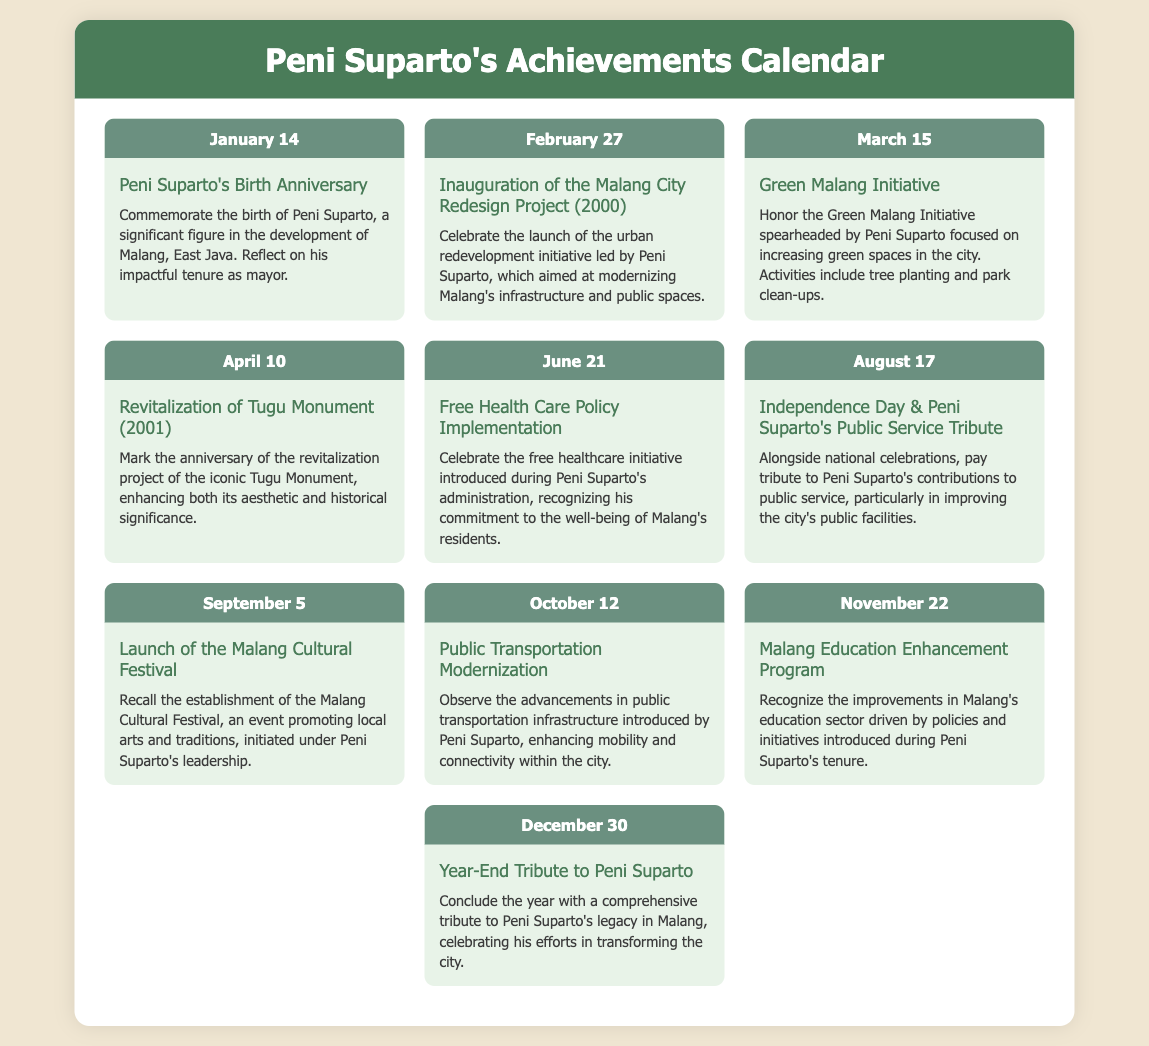What event is celebrated on January 14? The event celebrated on January 14 is Peni Suparto's Birth Anniversary, marked for his significance in Malang's development.
Answer: Peni Suparto's Birth Anniversary When was the Malang Cultural Festival launched? The Malang Cultural Festival was launched on September 5, as noted in the calendar.
Answer: September 5 What initiative was introduced on June 21? On June 21, the Free Health Care Policy Implementation was celebrated, introduced during Peni Suparto's administration.
Answer: Free Health Care Policy Implementation In which year did Peni Suparto's administration initiate the public transportation modernization? The public transportation modernization was noted on October 12, but the specific year is not mentioned in the document.
Answer: Not specified What is the focus of the Green Malang Initiative? The Green Malang Initiative, honored on March 15, focuses on increasing green spaces in the city through activities like tree planting and park clean-ups.
Answer: Increasing green spaces Which date is associated with the year-end tribute to Peni Suparto? The year-end tribute to Peni Suparto is on December 30, concluding the year with recognition of his legacy.
Answer: December 30 What was a significant event in Peni Suparto's tenure related to education? The event related to education is the Malang Education Enhancement Program, noted on November 22 for its improvements.
Answer: Malang Education Enhancement Program 